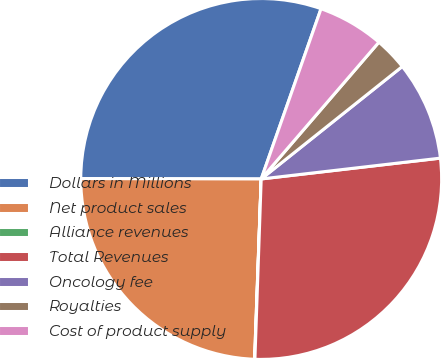<chart> <loc_0><loc_0><loc_500><loc_500><pie_chart><fcel>Dollars in Millions<fcel>Net product sales<fcel>Alliance revenues<fcel>Total Revenues<fcel>Oncology fee<fcel>Royalties<fcel>Cost of product supply<nl><fcel>30.35%<fcel>24.45%<fcel>0.03%<fcel>27.4%<fcel>8.87%<fcel>2.98%<fcel>5.93%<nl></chart> 